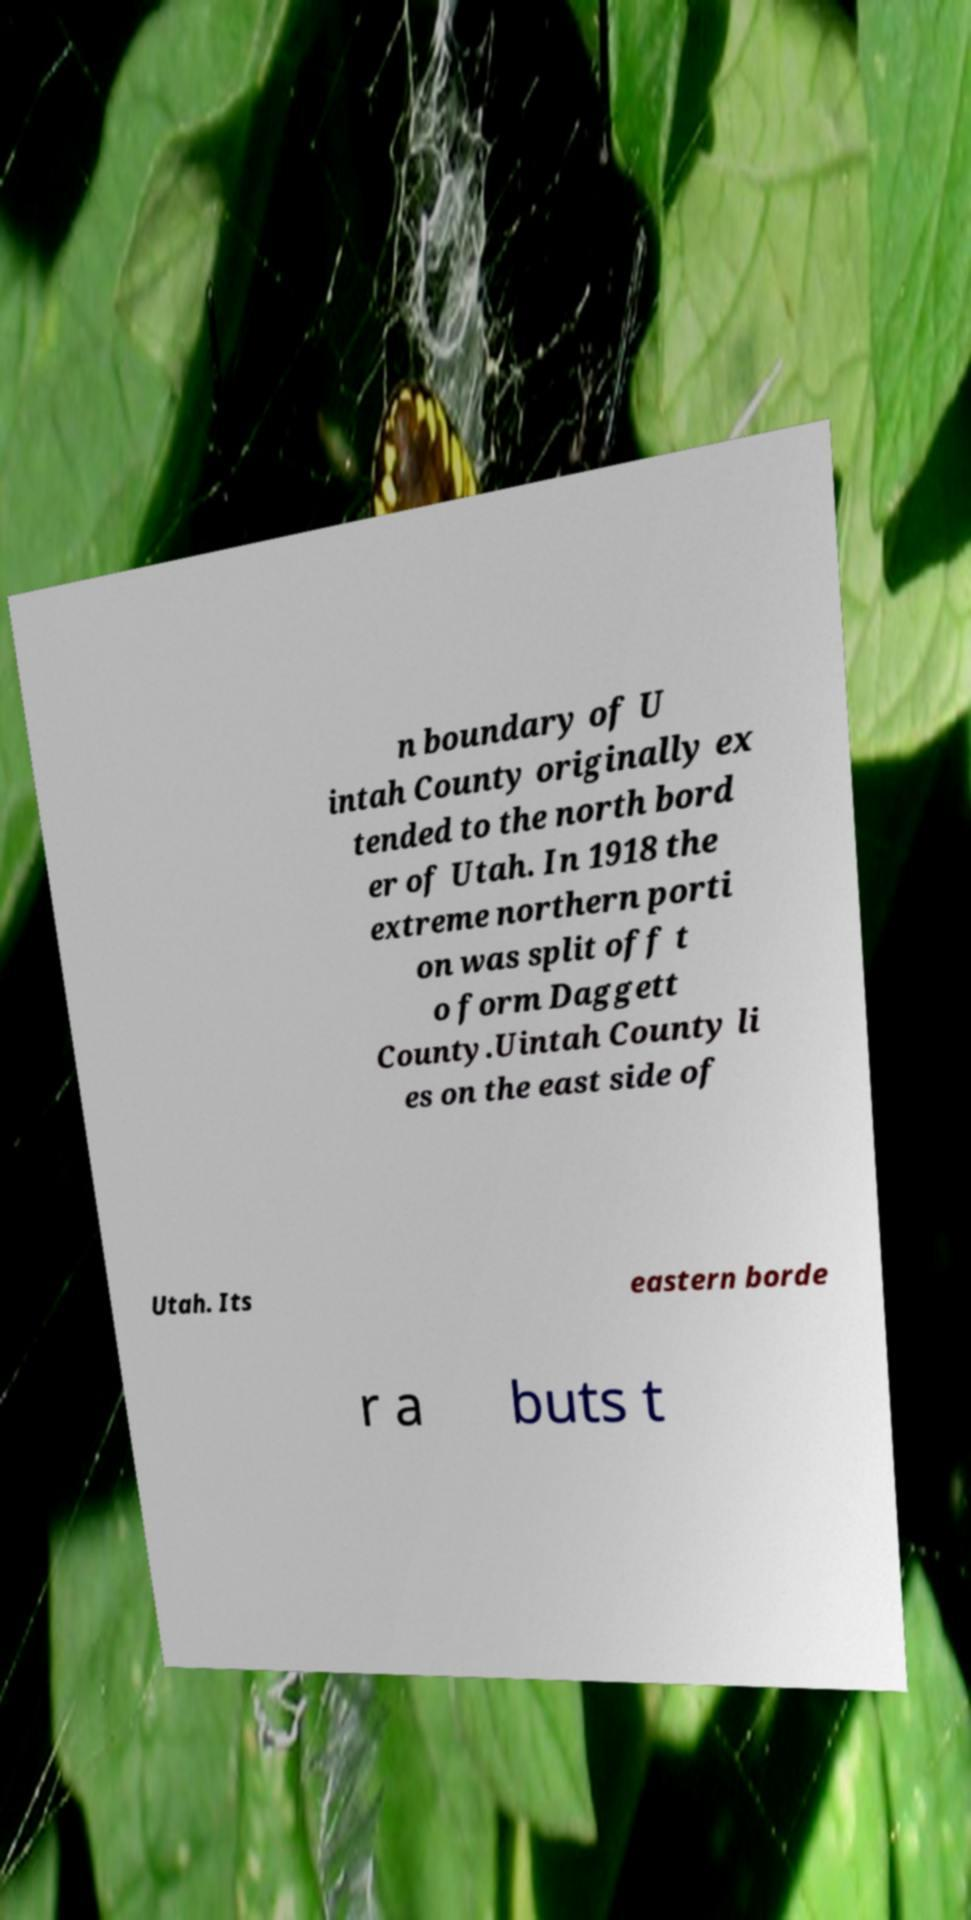What messages or text are displayed in this image? I need them in a readable, typed format. n boundary of U intah County originally ex tended to the north bord er of Utah. In 1918 the extreme northern porti on was split off t o form Daggett County.Uintah County li es on the east side of Utah. Its eastern borde r a buts t 